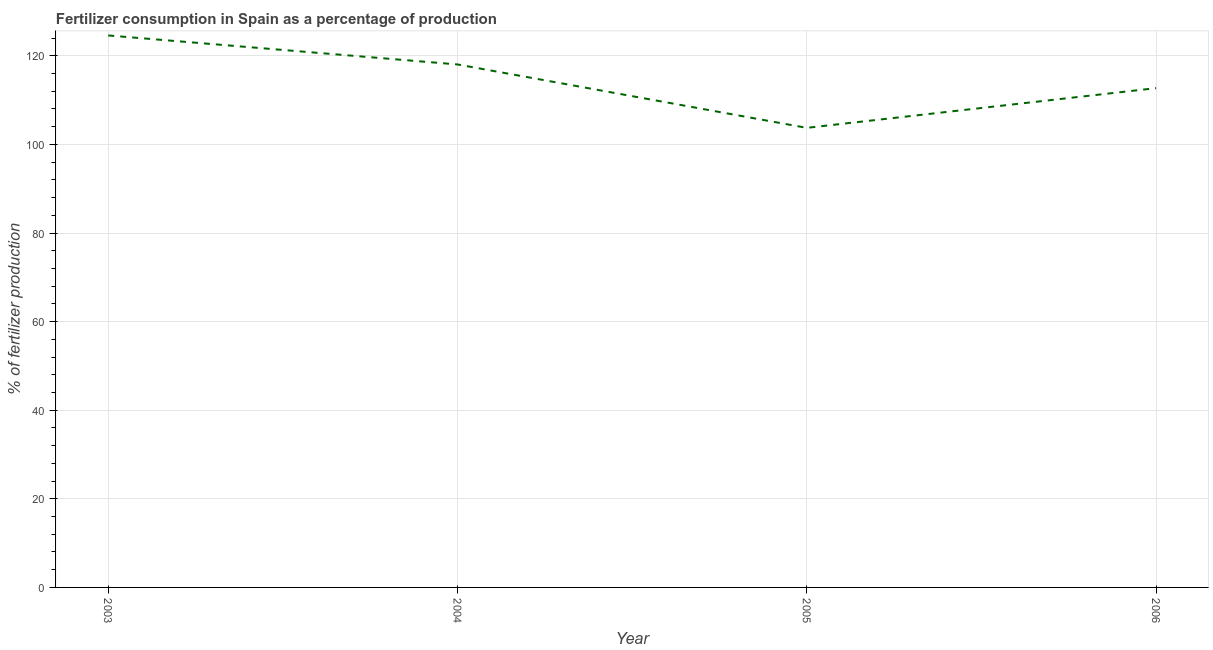What is the amount of fertilizer consumption in 2003?
Provide a short and direct response. 124.6. Across all years, what is the maximum amount of fertilizer consumption?
Your response must be concise. 124.6. Across all years, what is the minimum amount of fertilizer consumption?
Keep it short and to the point. 103.74. In which year was the amount of fertilizer consumption minimum?
Your answer should be compact. 2005. What is the sum of the amount of fertilizer consumption?
Keep it short and to the point. 459.09. What is the difference between the amount of fertilizer consumption in 2004 and 2005?
Keep it short and to the point. 14.31. What is the average amount of fertilizer consumption per year?
Offer a terse response. 114.77. What is the median amount of fertilizer consumption?
Give a very brief answer. 115.38. Do a majority of the years between 2004 and 2005 (inclusive) have amount of fertilizer consumption greater than 12 %?
Make the answer very short. Yes. What is the ratio of the amount of fertilizer consumption in 2004 to that in 2006?
Provide a succinct answer. 1.05. Is the amount of fertilizer consumption in 2004 less than that in 2005?
Make the answer very short. No. What is the difference between the highest and the second highest amount of fertilizer consumption?
Ensure brevity in your answer.  6.55. What is the difference between the highest and the lowest amount of fertilizer consumption?
Offer a very short reply. 20.86. In how many years, is the amount of fertilizer consumption greater than the average amount of fertilizer consumption taken over all years?
Give a very brief answer. 2. How many years are there in the graph?
Your answer should be compact. 4. What is the difference between two consecutive major ticks on the Y-axis?
Your answer should be very brief. 20. Are the values on the major ticks of Y-axis written in scientific E-notation?
Your response must be concise. No. Does the graph contain any zero values?
Provide a short and direct response. No. Does the graph contain grids?
Provide a short and direct response. Yes. What is the title of the graph?
Offer a very short reply. Fertilizer consumption in Spain as a percentage of production. What is the label or title of the X-axis?
Provide a succinct answer. Year. What is the label or title of the Y-axis?
Your response must be concise. % of fertilizer production. What is the % of fertilizer production in 2003?
Provide a succinct answer. 124.6. What is the % of fertilizer production in 2004?
Your response must be concise. 118.05. What is the % of fertilizer production in 2005?
Provide a short and direct response. 103.74. What is the % of fertilizer production of 2006?
Give a very brief answer. 112.71. What is the difference between the % of fertilizer production in 2003 and 2004?
Offer a very short reply. 6.55. What is the difference between the % of fertilizer production in 2003 and 2005?
Keep it short and to the point. 20.86. What is the difference between the % of fertilizer production in 2003 and 2006?
Ensure brevity in your answer.  11.89. What is the difference between the % of fertilizer production in 2004 and 2005?
Offer a very short reply. 14.31. What is the difference between the % of fertilizer production in 2004 and 2006?
Ensure brevity in your answer.  5.34. What is the difference between the % of fertilizer production in 2005 and 2006?
Offer a terse response. -8.97. What is the ratio of the % of fertilizer production in 2003 to that in 2004?
Give a very brief answer. 1.05. What is the ratio of the % of fertilizer production in 2003 to that in 2005?
Your answer should be compact. 1.2. What is the ratio of the % of fertilizer production in 2003 to that in 2006?
Ensure brevity in your answer.  1.1. What is the ratio of the % of fertilizer production in 2004 to that in 2005?
Your answer should be compact. 1.14. What is the ratio of the % of fertilizer production in 2004 to that in 2006?
Provide a succinct answer. 1.05. 